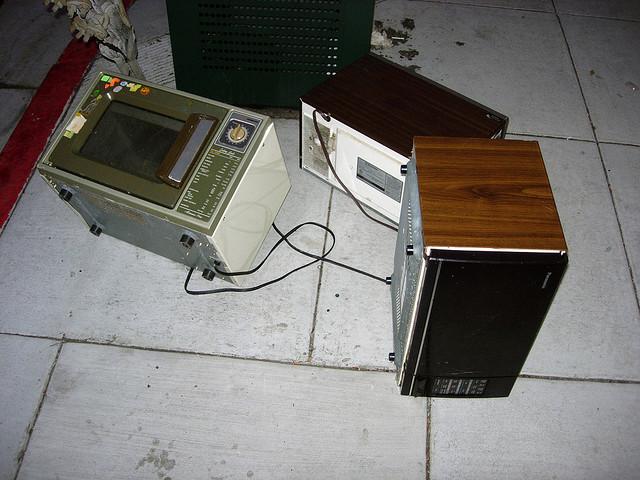Is the microwave in a kitchen?
Write a very short answer. No. What is this device?
Concise answer only. Microwave. Does the floor appear to be clean?
Quick response, please. No. Is this garbage?
Be succinct. No. What color is this microwave oven?
Short answer required. Brown. Are those microwaves old?
Write a very short answer. Yes. 